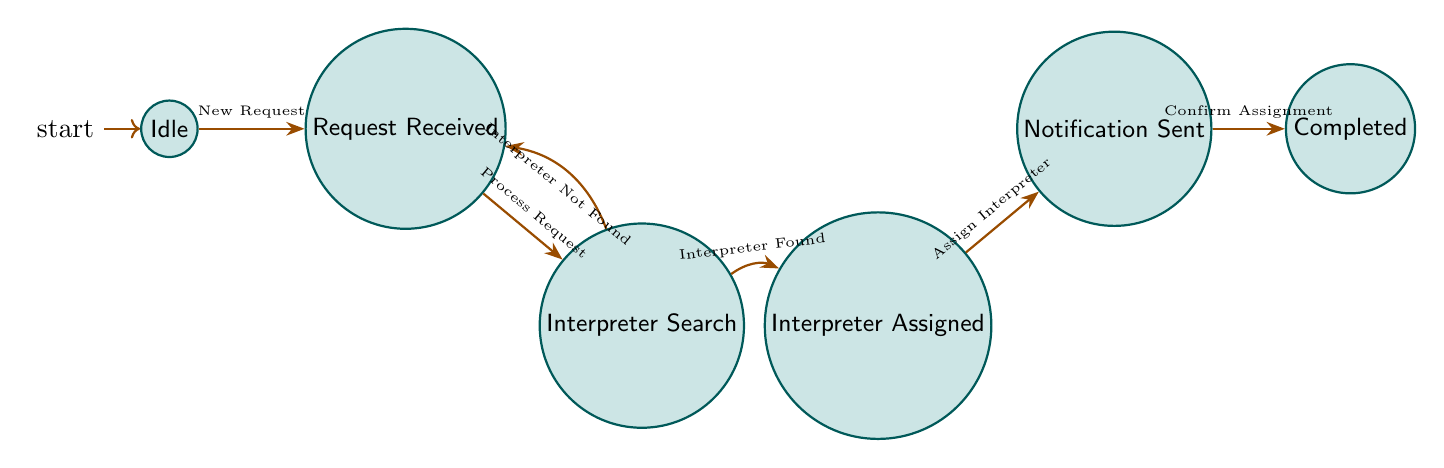What's the initial state of the system? The initial state is indicated by the "initial" label on the node, which is "Idle".
Answer: Idle How many states are in the diagram? Count the unique node representations to determine the total states, which are: Idle, Request Received, Interpreter Search, Interpreter Assigned, Notification Sent, and Completed, giving a total of 6 states.
Answer: 6 What is the transition that occurs from "Request Received"? The diagram indicates the transition from "Request Received" to "Interpreter Search" with the trigger "Process Request".
Answer: Interpreter Search Which state is entered after "Notification Sent"? The edge leading from "Notification Sent" points to the state "Completed", indicating that this is the next state after "Notification Sent".
Answer: Completed What triggers the transition from "Interpreter Search" back to "Request Received"? The transition is triggered by "Interpreter Not Found", as shown in the diagram, which leads back to the "Request Received" state.
Answer: Interpreter Not Found What is the final state of the machine? The final state is depicted as "Completed", which is reached after "Notification Sent".
Answer: Completed How many transitions are shown in the diagram? Each edge represents a transition, and by counting all the arrows connecting the states, there are a total of 6 transitions present in the diagram.
Answer: 6 What does the transition from "Interpreter Assigned" signify? The trigger "Assign Interpreter" indicates that an interpreter has been assigned successfully to the request, leading to the next state "Notification Sent".
Answer: Assign Interpreter 